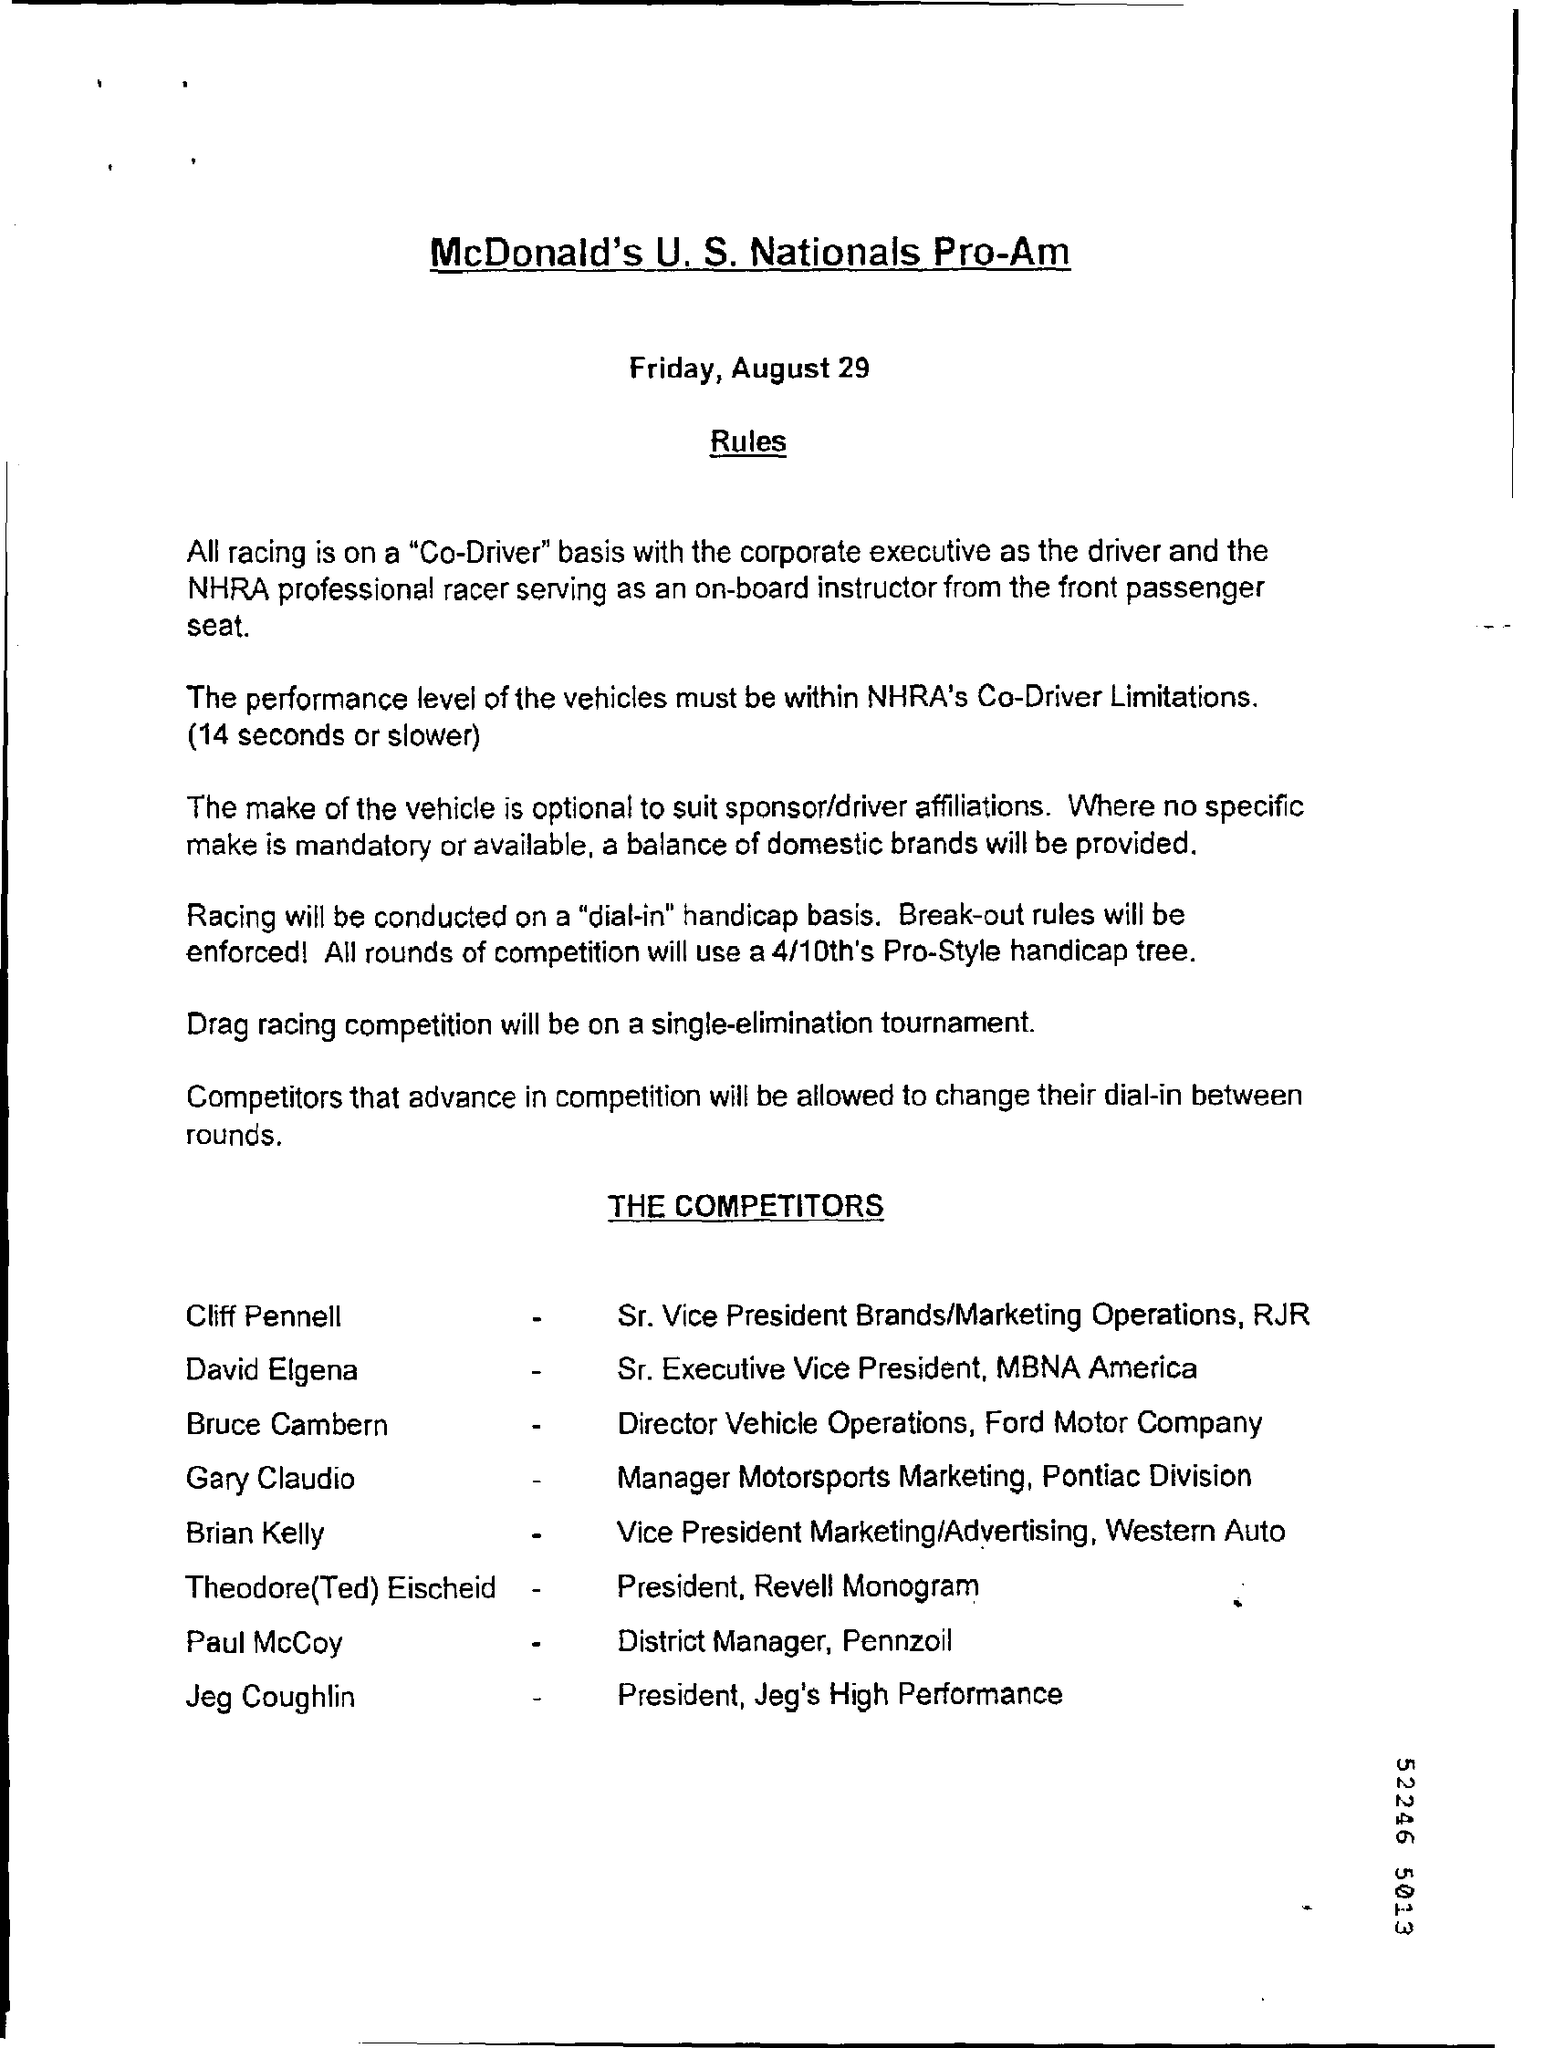What is the date mentioned at the top?
Your response must be concise. August 29. Drag racing competition will be on which tournament?
Provide a succinct answer. Single-elimination tournament. 